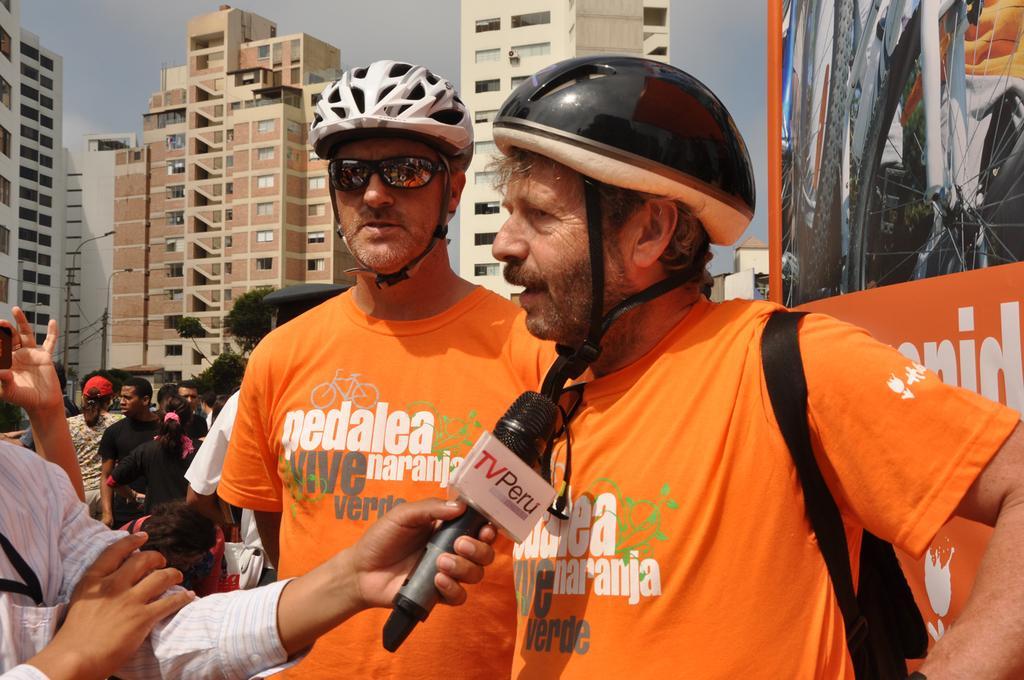Could you give a brief overview of what you see in this image? As we can see in the image there are few people here and there, banners, mic, helmets and buildings. On the top there is a sky. 